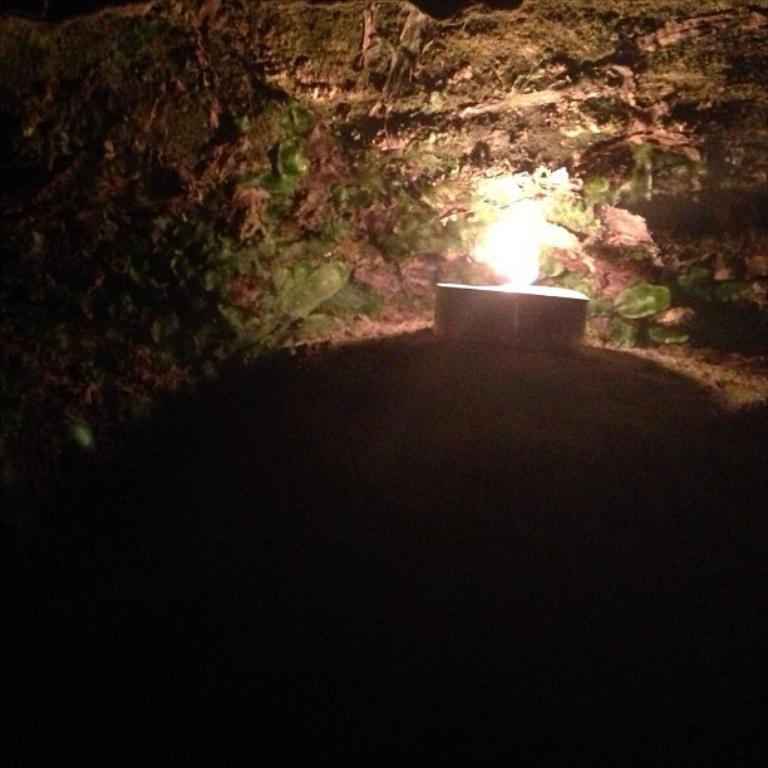Please provide a concise description of this image. In this image we can see a candle with flame placed on the ground. 